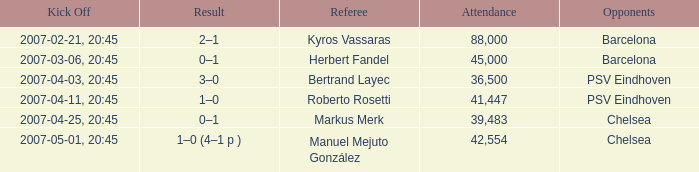WHAT WAS THE SCORE OF THE GAME WITH A 2007-03-06, 20:45 KICKOFF? 0–1. 